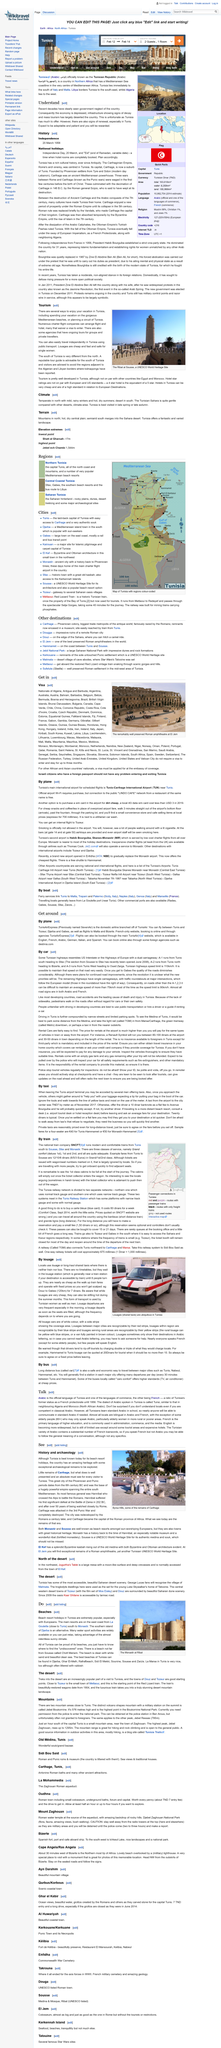Indicate a few pertinent items in this graphic. A Louage is a long-haul shared taxi that provides transportation services for passengers traveling over a distance. It is common for louage taxis to be used when there is no train or bus option available for a person's destination. It is not necessary to follow a timetable when using the louage as it does not adhere to one. 